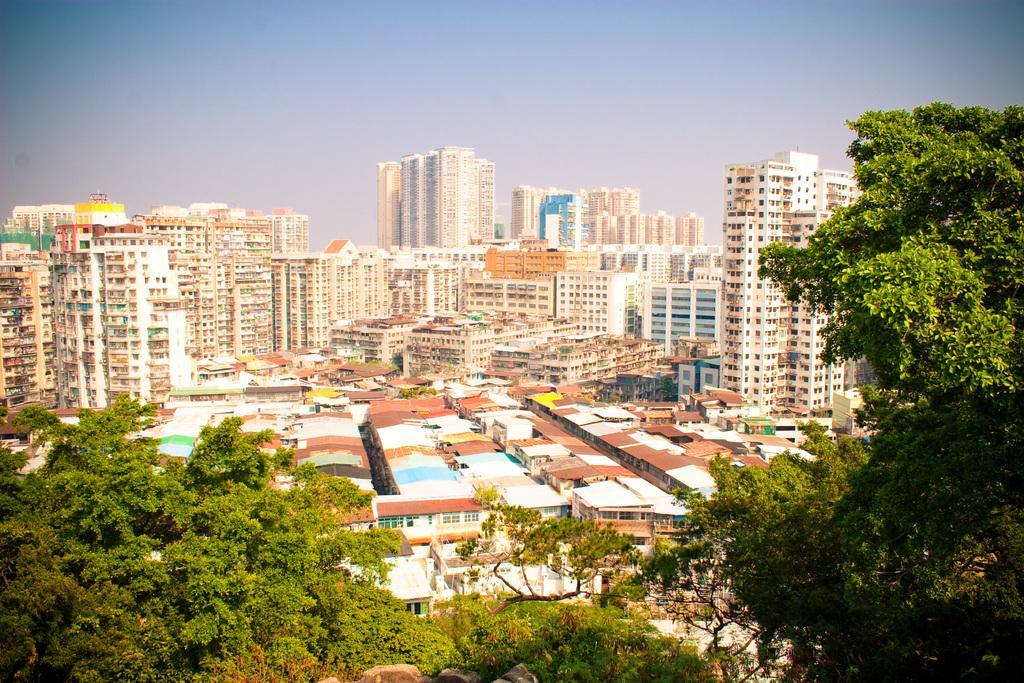Could you give a brief overview of what you see in this image? In this image I can see the trees. In the background, I can see the buildings and the sky. 